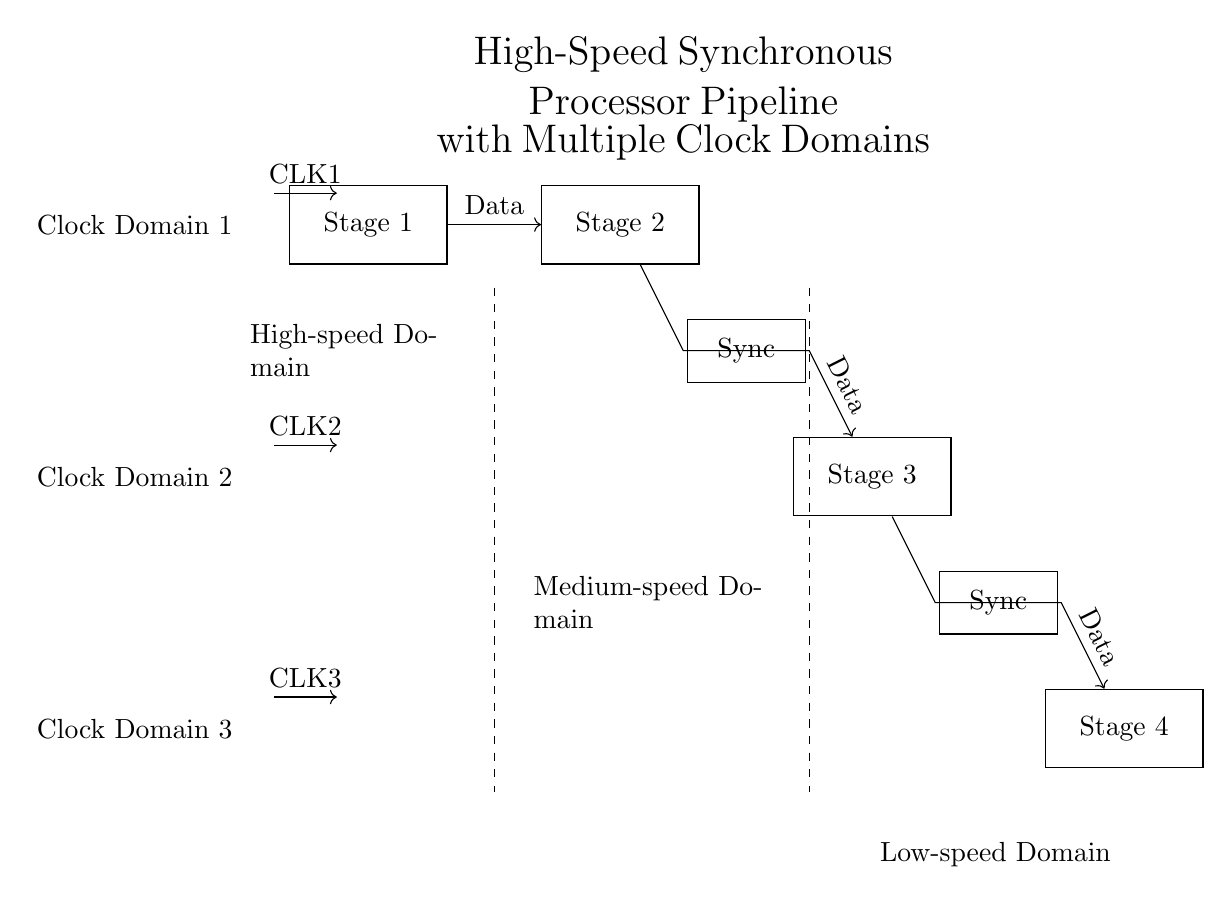What is the number of pipeline stages? There are four stages shown in the diagram: Stage 1, Stage 2, Stage 3, and Stage 4.
Answer: 4 What are the clock signals used in this circuit? The circuit uses three clock signals, labeled CLK1, CLK2, and CLK3, which correspond to the three different clock domains.
Answer: CLK1, CLK2, CLK3 Which clock domain is associated with Stage 2? Stage 2 is linked to Clock Domain 1, as indicated by the placement of the stage and the associated clock signal.
Answer: Clock Domain 1 How many synchronization elements are present? There are two synchronization elements in the diagram, located between different clock domains to manage data flow.
Answer: 2 What type of data flow occurs between Stage 2 and Stage 3? The data flow between Stage 2 and Stage 3 is facilitated by a synchronization element, signifying a transfer across clock domains.
Answer: Synchronized Data Flow Which clock domain is designated as the low-speed domain? The low-speed domain is defined as Clock Domain 3, which is at the bottom of the diagram and is associated with Stage 4.
Answer: Clock Domain 3 What is the alignment of the synchronization elements relative to the stages? The synchronization elements are placed between Stage 2 and Stage 3, as well as between Stage 3 and Stage 4, to synchronize the data flow across different clock domains.
Answer: Between Stages 2 and 3; Between Stages 3 and 4 